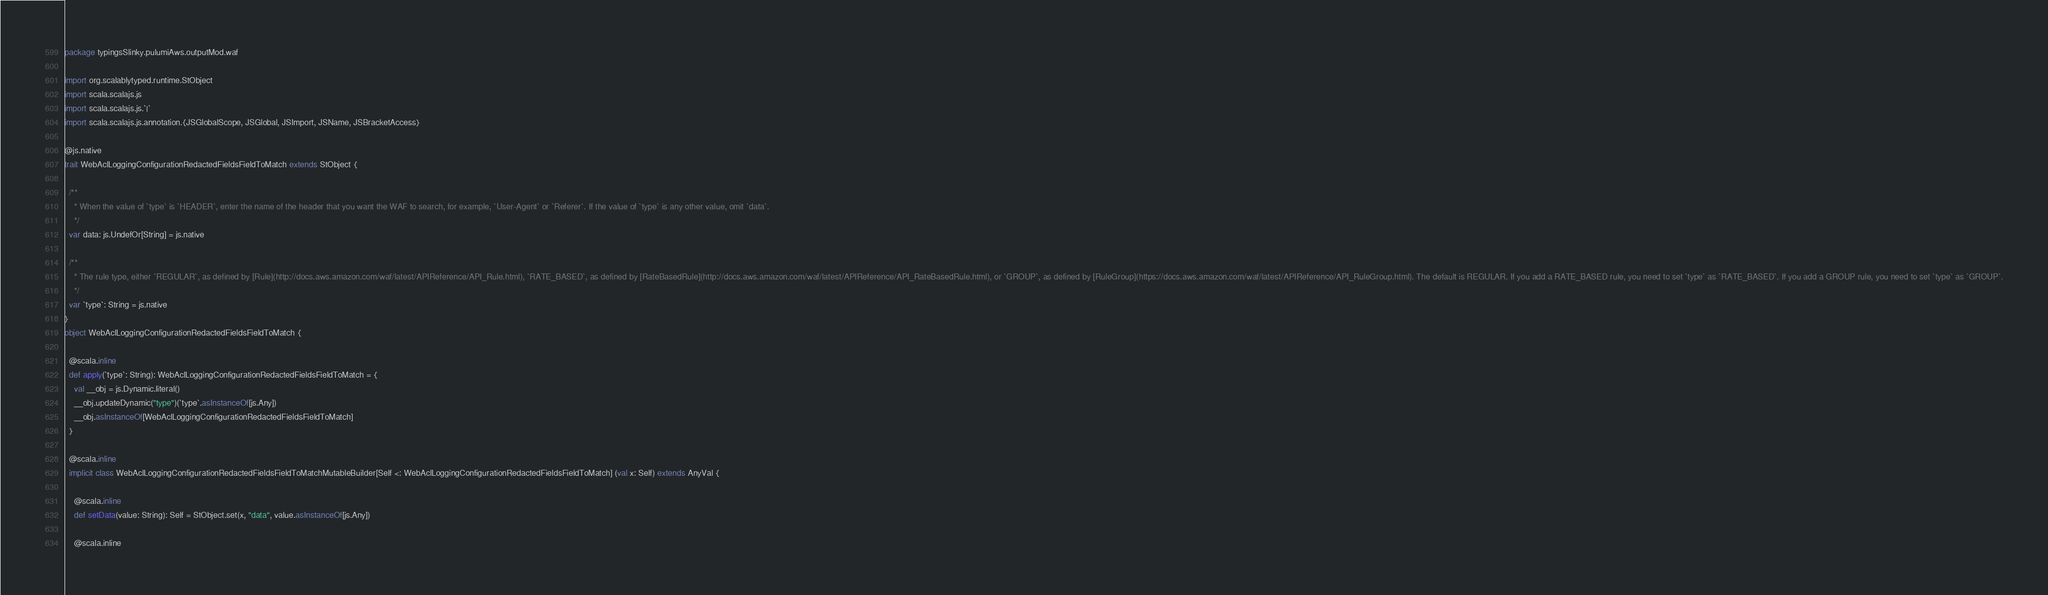<code> <loc_0><loc_0><loc_500><loc_500><_Scala_>package typingsSlinky.pulumiAws.outputMod.waf

import org.scalablytyped.runtime.StObject
import scala.scalajs.js
import scala.scalajs.js.`|`
import scala.scalajs.js.annotation.{JSGlobalScope, JSGlobal, JSImport, JSName, JSBracketAccess}

@js.native
trait WebAclLoggingConfigurationRedactedFieldsFieldToMatch extends StObject {
  
  /**
    * When the value of `type` is `HEADER`, enter the name of the header that you want the WAF to search, for example, `User-Agent` or `Referer`. If the value of `type` is any other value, omit `data`.
    */
  var data: js.UndefOr[String] = js.native
  
  /**
    * The rule type, either `REGULAR`, as defined by [Rule](http://docs.aws.amazon.com/waf/latest/APIReference/API_Rule.html), `RATE_BASED`, as defined by [RateBasedRule](http://docs.aws.amazon.com/waf/latest/APIReference/API_RateBasedRule.html), or `GROUP`, as defined by [RuleGroup](https://docs.aws.amazon.com/waf/latest/APIReference/API_RuleGroup.html). The default is REGULAR. If you add a RATE_BASED rule, you need to set `type` as `RATE_BASED`. If you add a GROUP rule, you need to set `type` as `GROUP`.
    */
  var `type`: String = js.native
}
object WebAclLoggingConfigurationRedactedFieldsFieldToMatch {
  
  @scala.inline
  def apply(`type`: String): WebAclLoggingConfigurationRedactedFieldsFieldToMatch = {
    val __obj = js.Dynamic.literal()
    __obj.updateDynamic("type")(`type`.asInstanceOf[js.Any])
    __obj.asInstanceOf[WebAclLoggingConfigurationRedactedFieldsFieldToMatch]
  }
  
  @scala.inline
  implicit class WebAclLoggingConfigurationRedactedFieldsFieldToMatchMutableBuilder[Self <: WebAclLoggingConfigurationRedactedFieldsFieldToMatch] (val x: Self) extends AnyVal {
    
    @scala.inline
    def setData(value: String): Self = StObject.set(x, "data", value.asInstanceOf[js.Any])
    
    @scala.inline</code> 